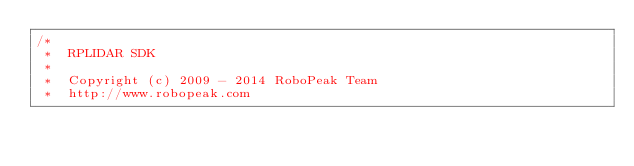Convert code to text. <code><loc_0><loc_0><loc_500><loc_500><_C_>/*
 *  RPLIDAR SDK
 *
 *  Copyright (c) 2009 - 2014 RoboPeak Team
 *  http://www.robopeak.com</code> 